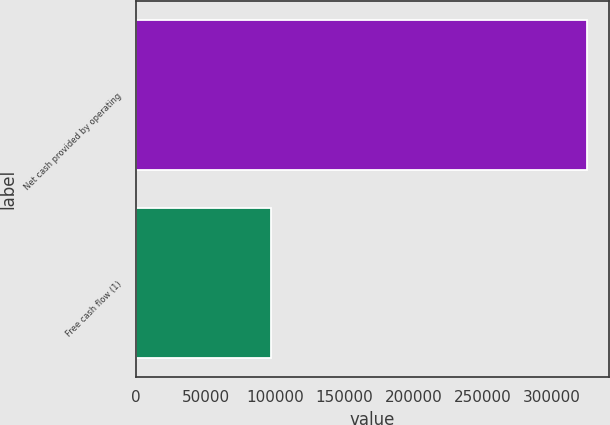Convert chart. <chart><loc_0><loc_0><loc_500><loc_500><bar_chart><fcel>Net cash provided by operating<fcel>Free cash flow (1)<nl><fcel>325063<fcel>97122<nl></chart> 